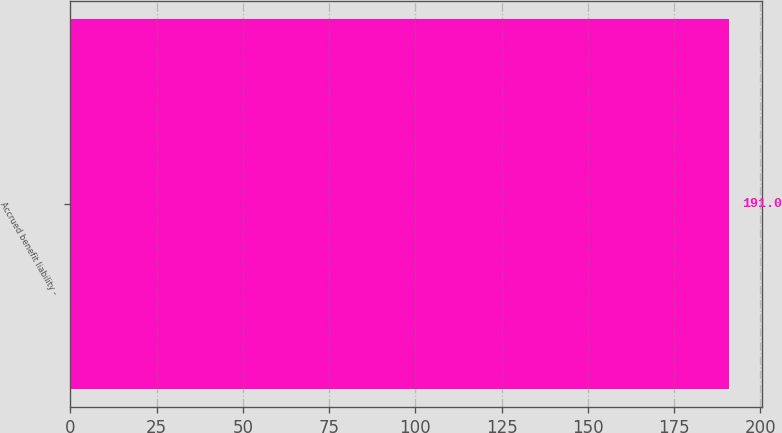Convert chart to OTSL. <chart><loc_0><loc_0><loc_500><loc_500><bar_chart><fcel>Accrued benefit liability -<nl><fcel>191<nl></chart> 